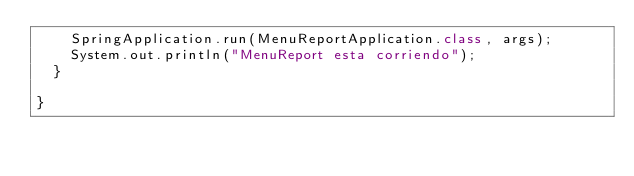<code> <loc_0><loc_0><loc_500><loc_500><_Java_>		SpringApplication.run(MenuReportApplication.class, args);
		System.out.println("MenuReport esta corriendo");
	}

}
</code> 